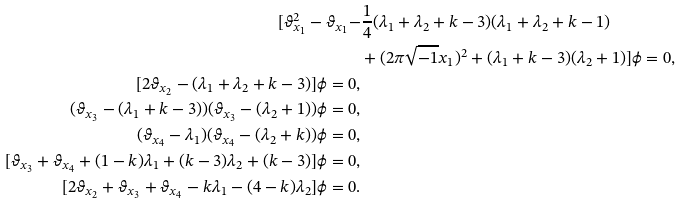Convert formula to latex. <formula><loc_0><loc_0><loc_500><loc_500>[ \vartheta _ { x _ { 1 } } ^ { 2 } - \vartheta _ { x _ { 1 } } - & \frac { 1 } { 4 } ( \lambda _ { 1 } + \lambda _ { 2 } + k - 3 ) ( \lambda _ { 1 } + \lambda _ { 2 } + k - 1 ) \\ & + ( 2 \pi \sqrt { - 1 } x _ { 1 } ) ^ { 2 } + ( \lambda _ { 1 } + k - 3 ) ( \lambda _ { 2 } + 1 ) ] \phi = 0 , \\ [ 2 \vartheta _ { x _ { 2 } } - ( \lambda _ { 1 } + \lambda _ { 2 } + k - 3 ) ] \phi = 0 , \\ ( \vartheta _ { x _ { 3 } } - ( \lambda _ { 1 } + k - 3 ) ) ( \vartheta _ { x _ { 3 } } - ( \lambda _ { 2 } + 1 ) ) \phi = 0 , \\ ( \vartheta _ { x _ { 4 } } - \lambda _ { 1 } ) ( \vartheta _ { x _ { 4 } } - ( \lambda _ { 2 } + k ) ) \phi = 0 , \\ [ \vartheta _ { x _ { 3 } } + \vartheta _ { x _ { 4 } } + ( 1 - k ) \lambda _ { 1 } + ( k - 3 ) \lambda _ { 2 } + ( k - 3 ) ] \phi = 0 , \\ [ 2 \vartheta _ { x _ { 2 } } + \vartheta _ { x _ { 3 } } + \vartheta _ { x _ { 4 } } - k \lambda _ { 1 } - ( 4 - k ) \lambda _ { 2 } ] \phi = 0 .</formula> 